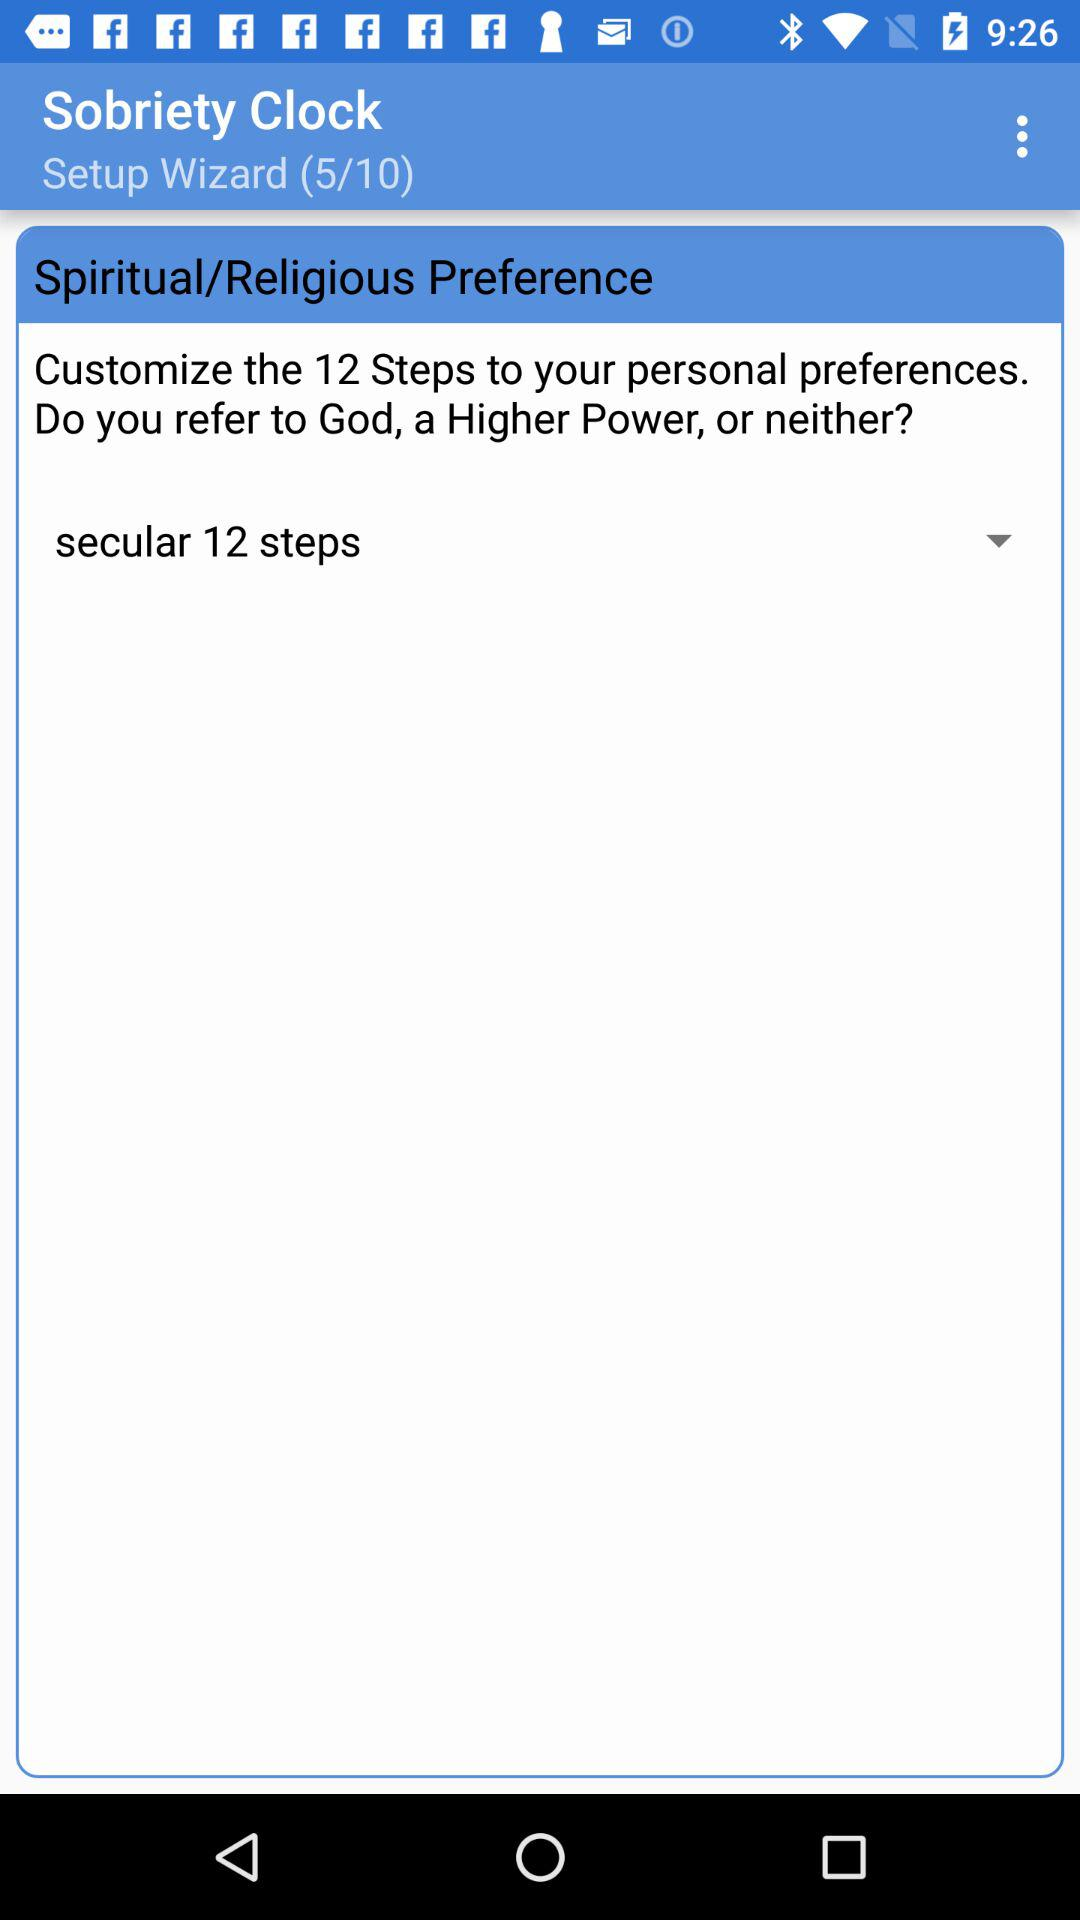How many religious options are there?
Answer the question using a single word or phrase. 3 